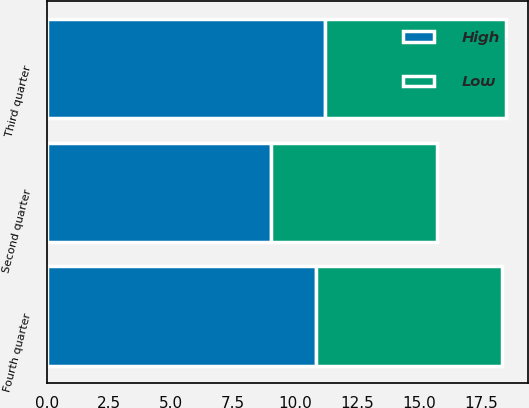Convert chart to OTSL. <chart><loc_0><loc_0><loc_500><loc_500><stacked_bar_chart><ecel><fcel>Second quarter<fcel>Third quarter<fcel>Fourth quarter<nl><fcel>High<fcel>9.03<fcel>11.2<fcel>10.85<nl><fcel>Low<fcel>6.71<fcel>7.28<fcel>7.47<nl></chart> 